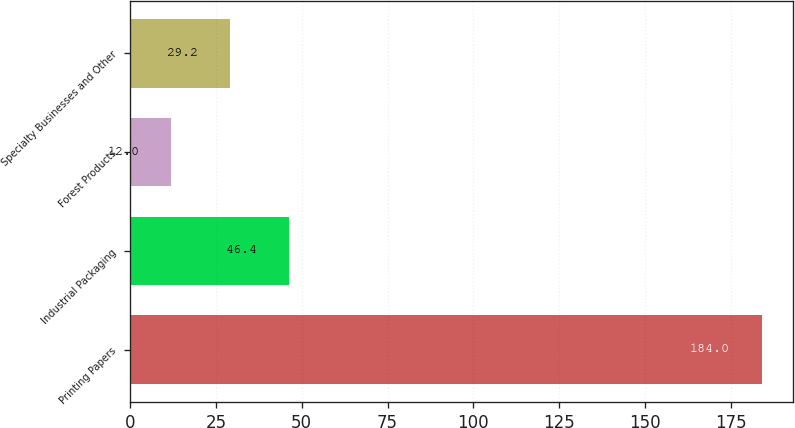Convert chart. <chart><loc_0><loc_0><loc_500><loc_500><bar_chart><fcel>Printing Papers<fcel>Industrial Packaging<fcel>Forest Products<fcel>Specialty Businesses and Other<nl><fcel>184<fcel>46.4<fcel>12<fcel>29.2<nl></chart> 